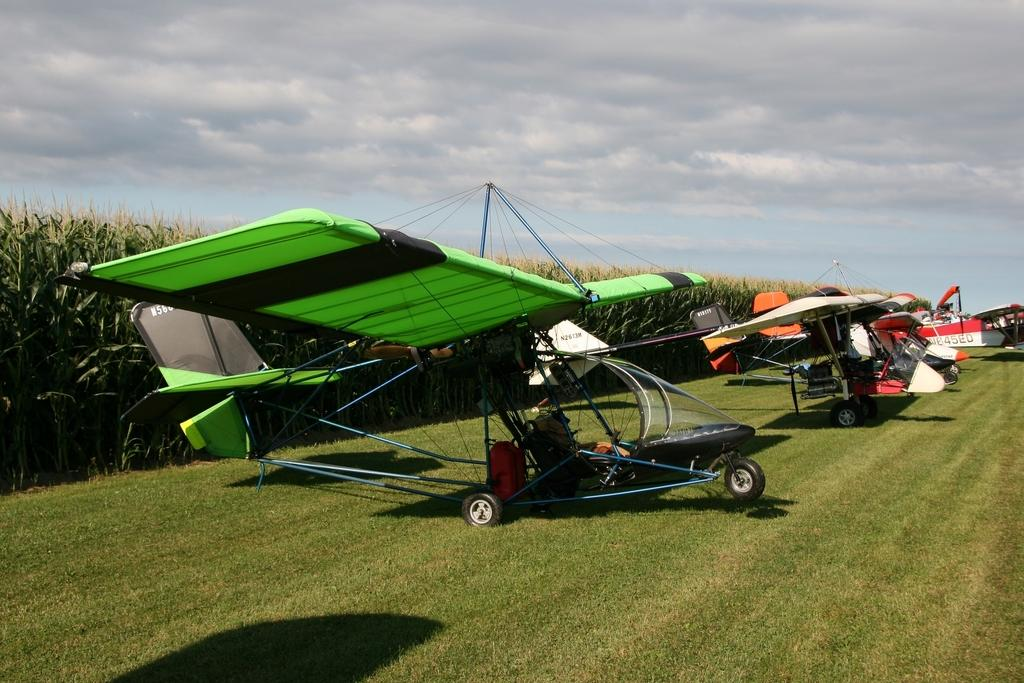What is the flying object doing in the image? The flying object is on the ground in the image. What can be seen in the background of the image? The background of the image is the sky. How does the flying object care for the plants in the image? The flying object does not care for plants in the image, as there is no mention of plants in the provided facts. 